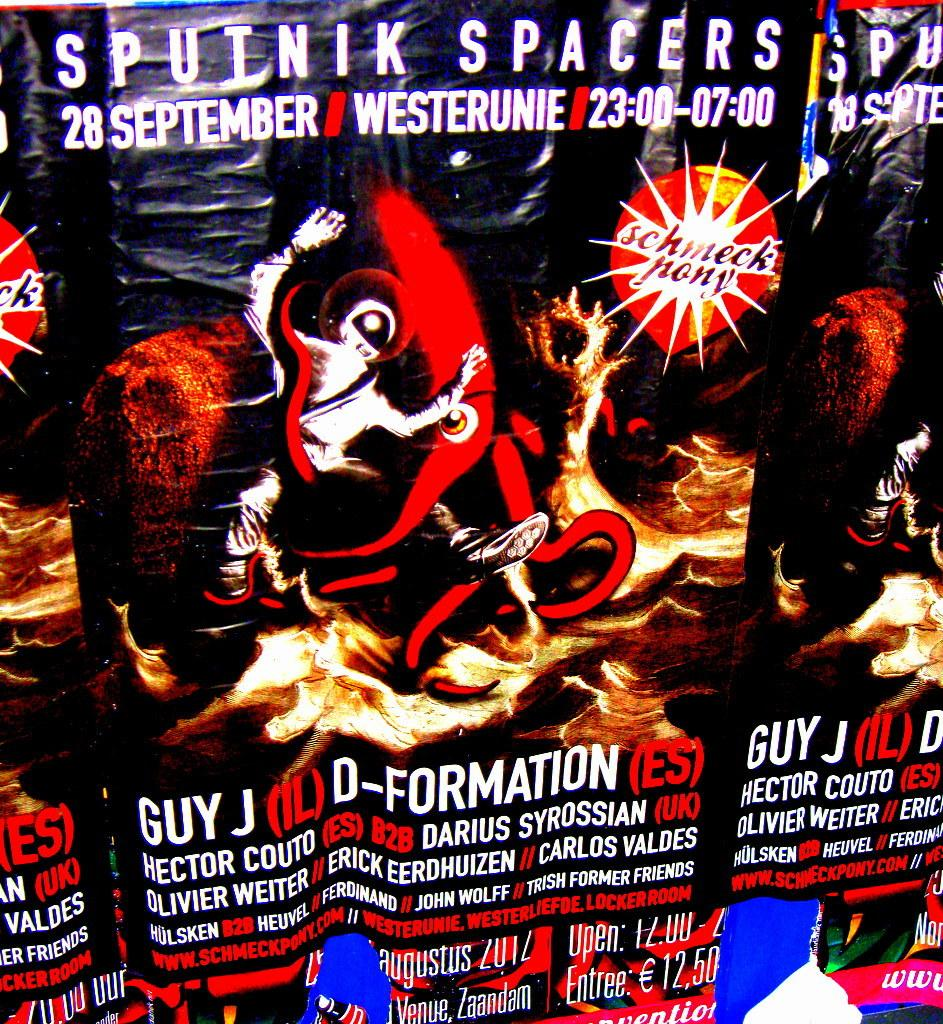<image>
Provide a brief description of the given image. A poster says Sputnik Spacers and shows cartoon astronauts in fire. 